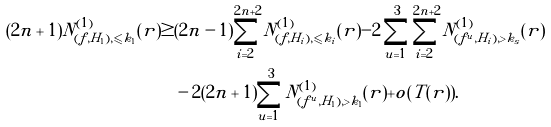Convert formula to latex. <formula><loc_0><loc_0><loc_500><loc_500>( 2 n + 1 ) N ^ { ( 1 ) } _ { ( f , H _ { 1 } ) , \leqslant k _ { 1 } } ( r ) \geq & ( 2 n - 1 ) \sum _ { i = 2 } ^ { 2 n + 2 } N ^ { ( 1 ) } _ { ( f , H _ { i } ) , \leqslant k _ { i } } ( r ) - 2 \sum _ { u = 1 } ^ { 3 } \sum _ { i = 2 } ^ { 2 n + 2 } N ^ { ( 1 ) } _ { ( f ^ { u } , H _ { i } ) , > k _ { s } } ( r ) \\ & - 2 ( 2 n + 1 ) \sum _ { u = 1 } ^ { 3 } N ^ { ( 1 ) } _ { ( f ^ { u } , H _ { 1 } ) , > k _ { 1 } } ( r ) + o ( T ( r ) ) .</formula> 